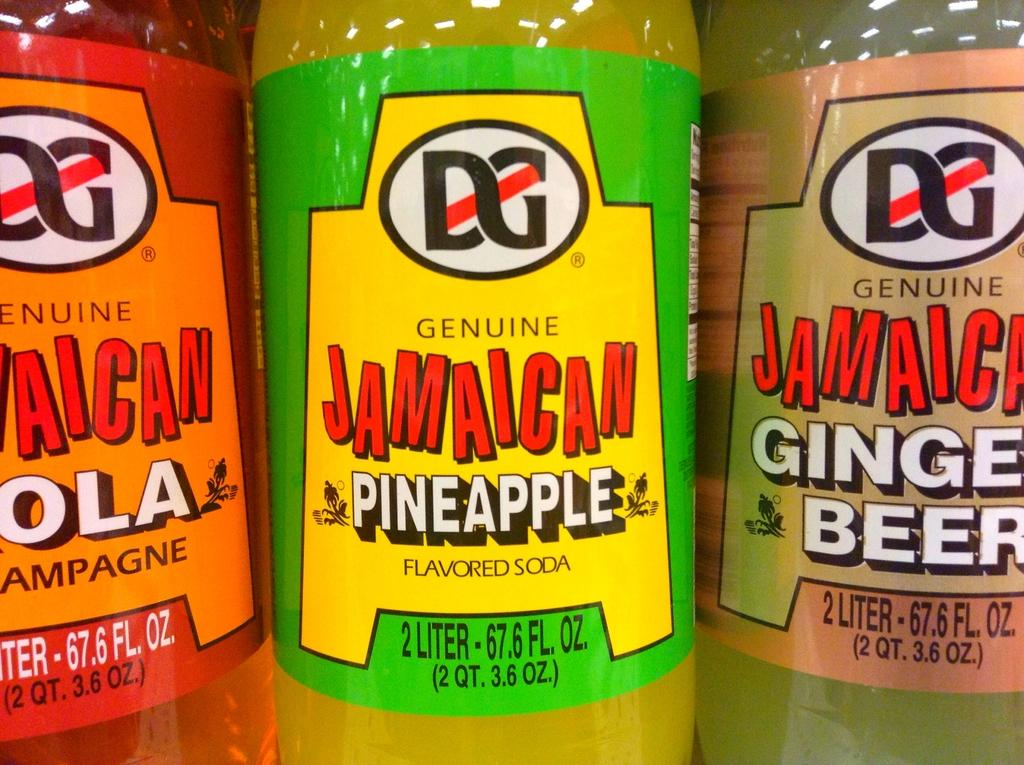<image>
Give a short and clear explanation of the subsequent image. A bottle of pineapple soda sits with some other bottles. 